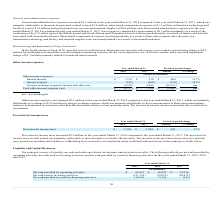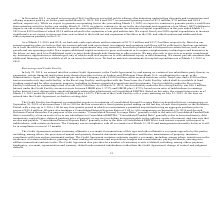According to Mimecast Limited's financial document, What are the principal sources of liquidity? cash and cash equivalents, investments and accounts receivable.. The document states: "Our principal sources of liquidity are cash and cash equivalents, investments and accounts receivable. The following table shows net cash provided by..." Also, What was the net proceeds raised in 2015? According to the financial document, $68.3 million. The relevant text states: "In November 2015, we raised net proceeds of $68.3 million in our initial public offering after deducting underwriting discounts and commissions and..." Also, What was the Net cash provided by operating activities in 2019, 2018 and 2017 respectively? The document contains multiple relevant values: $66,235, $46,412, $32,514 (in thousands). From the document: "cash provided by operating activities $ 66,235 $ 46,412 $ 32,514 vided by operating activities $ 66,235 $ 46,412 $ 32,514 Net cash provided by operati..." Also, can you calculate: What was the change in the Net cash provided by operating activities from 2018 to 2019? Based on the calculation: 66,235 - 46,412, the result is 19823 (in thousands). This is based on the information: "Net cash provided by operating activities $ 66,235 $ 46,412 $ 32,514 cash provided by operating activities $ 66,235 $ 46,412 $ 32,514..." The key data points involved are: 46,412, 66,235. Also, can you calculate: What was the average Net cash used in investing activities between 2017 to 2019? To answer this question, I need to perform calculations using the financial data. The calculation is: -(121,324 + 35,019 + 84,615) / 3, which equals -80319.33 (in thousands). This is based on the information: "used in investing activities (121,324) (35,019) (84,615) Net cash used in investing activities (121,324) (35,019) (84,615) Net cash used in investing activities (121,324) (35,019) (84,615)..." The key data points involved are: 121,324, 35,019, 84,615. Additionally, In which year was Net cash provided by (used in) financing activities less than 25,000 thousands? The document shows two values: 2018 and 2017. Locate and analyze net cash provided by (used in) financing activities in row 6. From the document: "2019 2018 2017 2019 2018 2017..." 